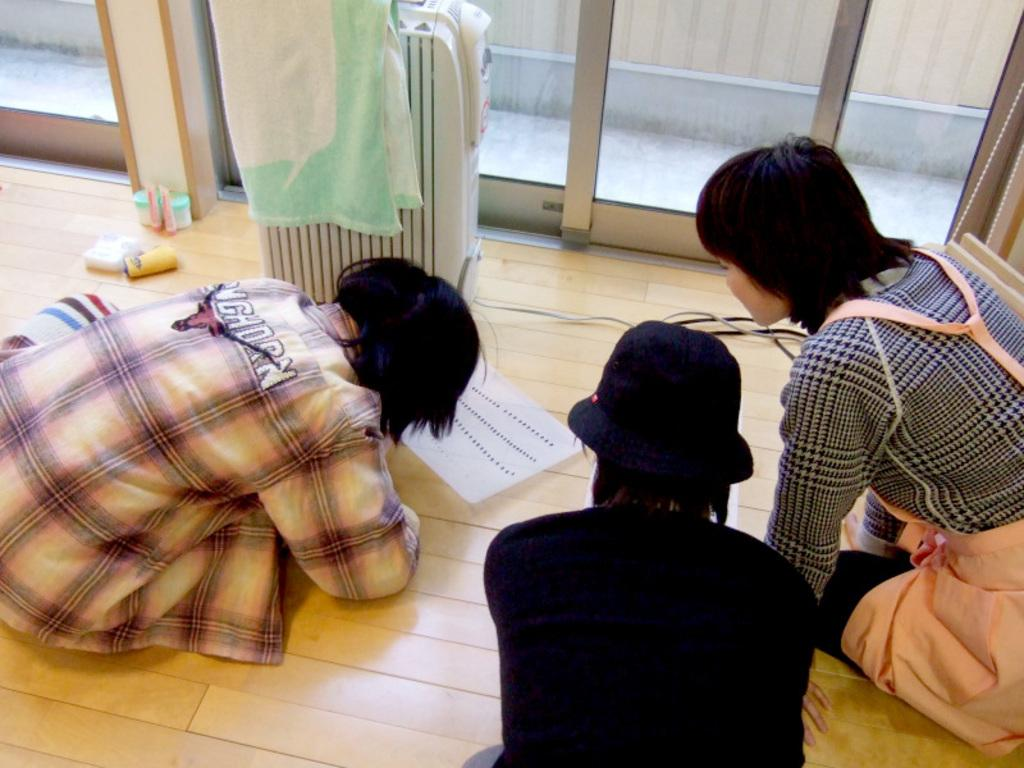Where are the people sitting in the image? The people are sitting on the floor on both the right and left sides of the image. What can be seen at the top side of the image? There are glass windows at the top side of the image. What type of cakes can be smelled in the image? There is no mention of cakes or any smell in the image, so it cannot be determined from the image. 